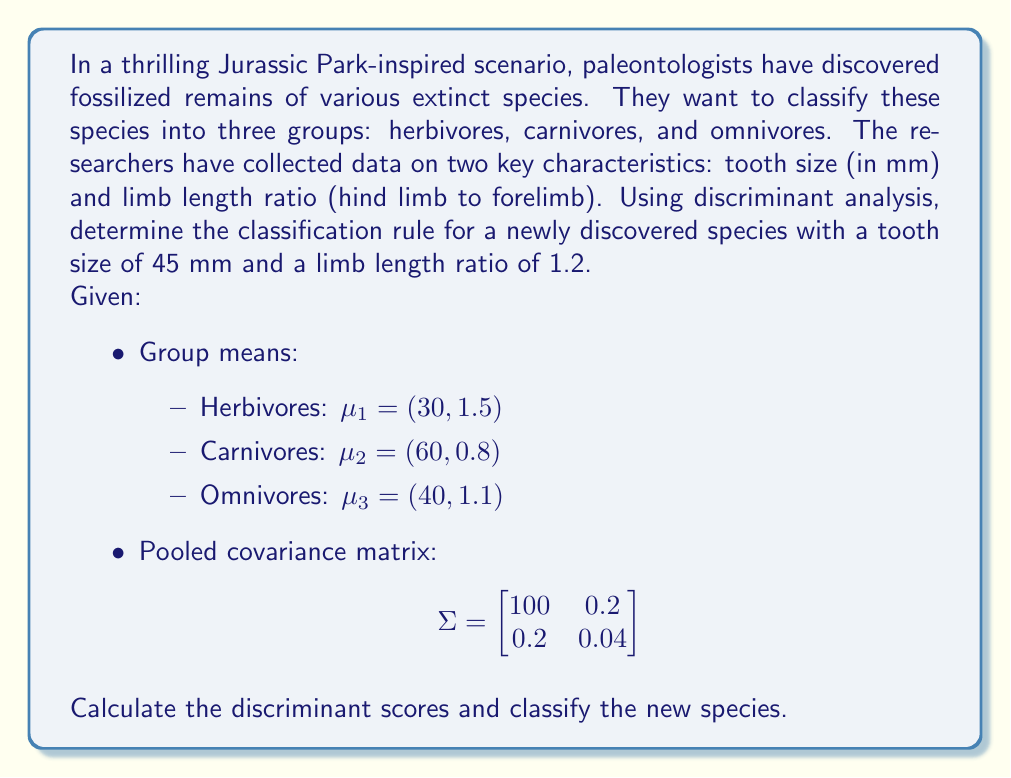Can you solve this math problem? To solve this Crichton-esque prehistoric classification problem, we'll use linear discriminant analysis. The steps are as follows:

1) First, we need to calculate the inverse of the pooled covariance matrix:

   $$\Sigma^{-1} = \begin{bmatrix}
   0.0100 & -0.0500 \\
   -0.0500 & 25.0500
   \end{bmatrix}$$

2) Now, we'll calculate the discriminant function for each group:

   $d_i(x) = x^T\Sigma^{-1}\mu_i - \frac{1}{2}\mu_i^T\Sigma^{-1}\mu_i + \ln(p_i)$

   Where $x$ is the new observation, $\mu_i$ is the mean of group $i$, and $p_i$ is the prior probability (assumed equal for all groups, so we can ignore this term).

3) Let's calculate $\mu_i^T\Sigma^{-1}\mu_i$ for each group:

   Herbivores: $30(0.0100) + 1.5(-0.0500) + 30(-0.0500) + 1.5(25.0500) = 37.65$
   Carnivores: $60(0.0100) + 0.8(-0.0500) + 60(-0.0500) + 0.8(25.0500) = 20.32$
   Omnivores: $40(0.0100) + 1.1(-0.0500) + 40(-0.0500) + 1.1(25.0500) = 27.505$

4) Now, let's calculate $x^T\Sigma^{-1}\mu_i$ for each group:

   Herbivores: $45(0.0100) + 1.2(-0.0500) + 30(-0.0500) + 1.5(25.0500) = 37.17$
   Carnivores: $45(0.0100) + 1.2(-0.0500) + 60(-0.0500) + 0.8(25.0500) = 19.68$
   Omnivores: $45(0.0100) + 1.2(-0.0500) + 40(-0.0500) + 1.1(25.0500) = 27.03$

5) Finally, we can calculate the discriminant scores:

   $d_1(x) = 37.17 - \frac{1}{2}(37.65) = 18.345$
   $d_2(x) = 19.68 - \frac{1}{2}(20.32) = 9.52$
   $d_3(x) = 27.03 - \frac{1}{2}(27.505) = 13.2775$

6) The species is classified into the group with the highest discriminant score.
Answer: The newly discovered species is classified as a herbivore, as $d_1(x) = 18.345$ is the highest discriminant score among the three groups. 